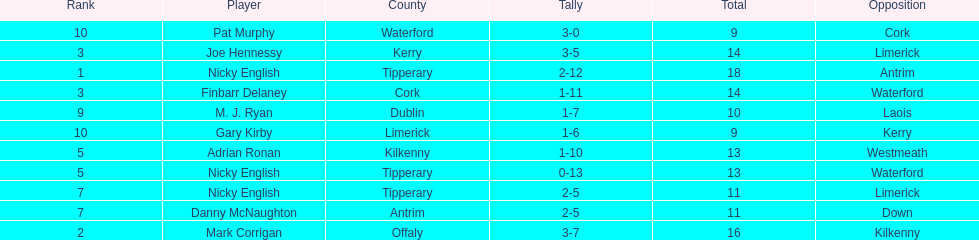What is the first name on the list? Nicky English. I'm looking to parse the entire table for insights. Could you assist me with that? {'header': ['Rank', 'Player', 'County', 'Tally', 'Total', 'Opposition'], 'rows': [['10', 'Pat Murphy', 'Waterford', '3-0', '9', 'Cork'], ['3', 'Joe Hennessy', 'Kerry', '3-5', '14', 'Limerick'], ['1', 'Nicky English', 'Tipperary', '2-12', '18', 'Antrim'], ['3', 'Finbarr Delaney', 'Cork', '1-11', '14', 'Waterford'], ['9', 'M. J. Ryan', 'Dublin', '1-7', '10', 'Laois'], ['10', 'Gary Kirby', 'Limerick', '1-6', '9', 'Kerry'], ['5', 'Adrian Ronan', 'Kilkenny', '1-10', '13', 'Westmeath'], ['5', 'Nicky English', 'Tipperary', '0-13', '13', 'Waterford'], ['7', 'Nicky English', 'Tipperary', '2-5', '11', 'Limerick'], ['7', 'Danny McNaughton', 'Antrim', '2-5', '11', 'Down'], ['2', 'Mark Corrigan', 'Offaly', '3-7', '16', 'Kilkenny']]} 